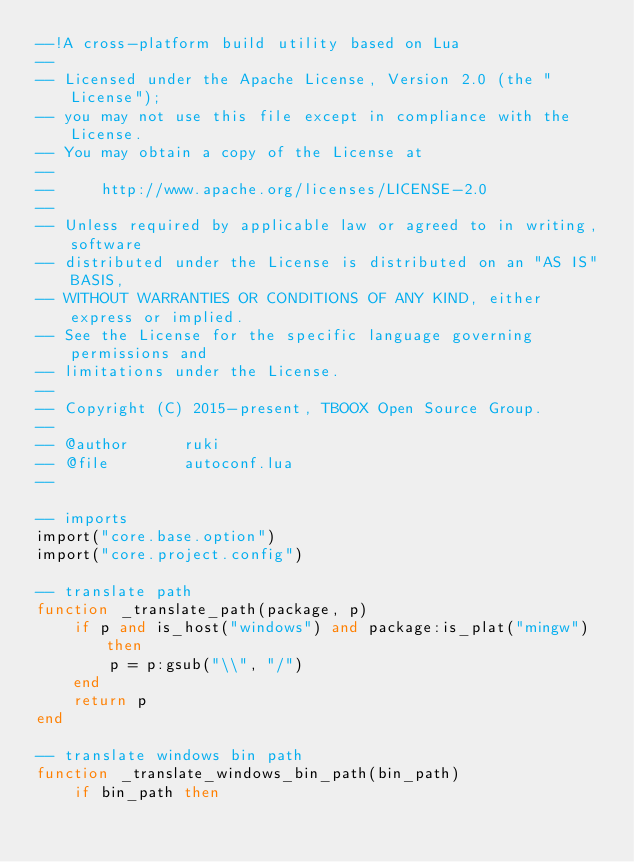Convert code to text. <code><loc_0><loc_0><loc_500><loc_500><_Lua_>--!A cross-platform build utility based on Lua
--
-- Licensed under the Apache License, Version 2.0 (the "License");
-- you may not use this file except in compliance with the License.
-- You may obtain a copy of the License at
--
--     http://www.apache.org/licenses/LICENSE-2.0
--
-- Unless required by applicable law or agreed to in writing, software
-- distributed under the License is distributed on an "AS IS" BASIS,
-- WITHOUT WARRANTIES OR CONDITIONS OF ANY KIND, either express or implied.
-- See the License for the specific language governing permissions and
-- limitations under the License.
--
-- Copyright (C) 2015-present, TBOOX Open Source Group.
--
-- @author      ruki
-- @file        autoconf.lua
--

-- imports
import("core.base.option")
import("core.project.config")

-- translate path
function _translate_path(package, p)
    if p and is_host("windows") and package:is_plat("mingw") then
        p = p:gsub("\\", "/")
    end
    return p
end

-- translate windows bin path
function _translate_windows_bin_path(bin_path)
    if bin_path then</code> 